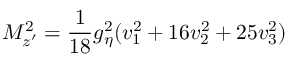<formula> <loc_0><loc_0><loc_500><loc_500>M _ { z ^ { \prime } } ^ { 2 } = \frac { 1 } { 1 8 } g _ { \eta } ^ { 2 } ( v _ { 1 } ^ { 2 } + 1 6 v _ { 2 } ^ { 2 } + 2 5 v _ { 3 } ^ { 2 } )</formula> 